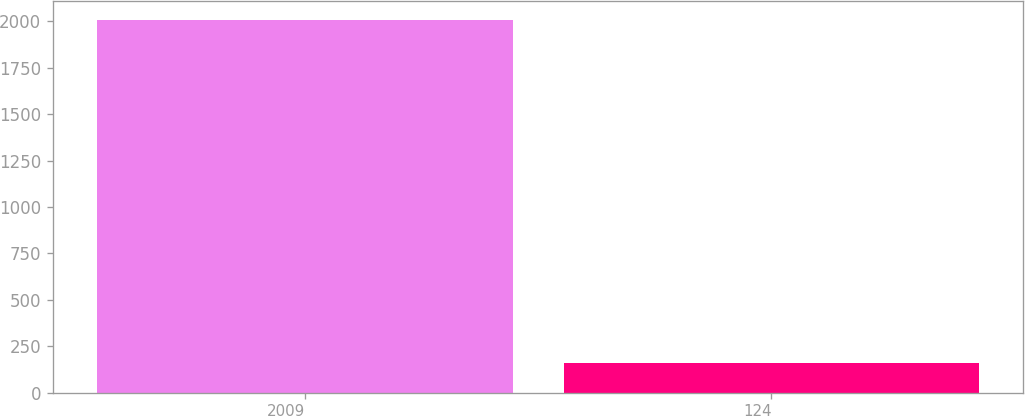Convert chart to OTSL. <chart><loc_0><loc_0><loc_500><loc_500><bar_chart><fcel>2009<fcel>124<nl><fcel>2008<fcel>158<nl></chart> 